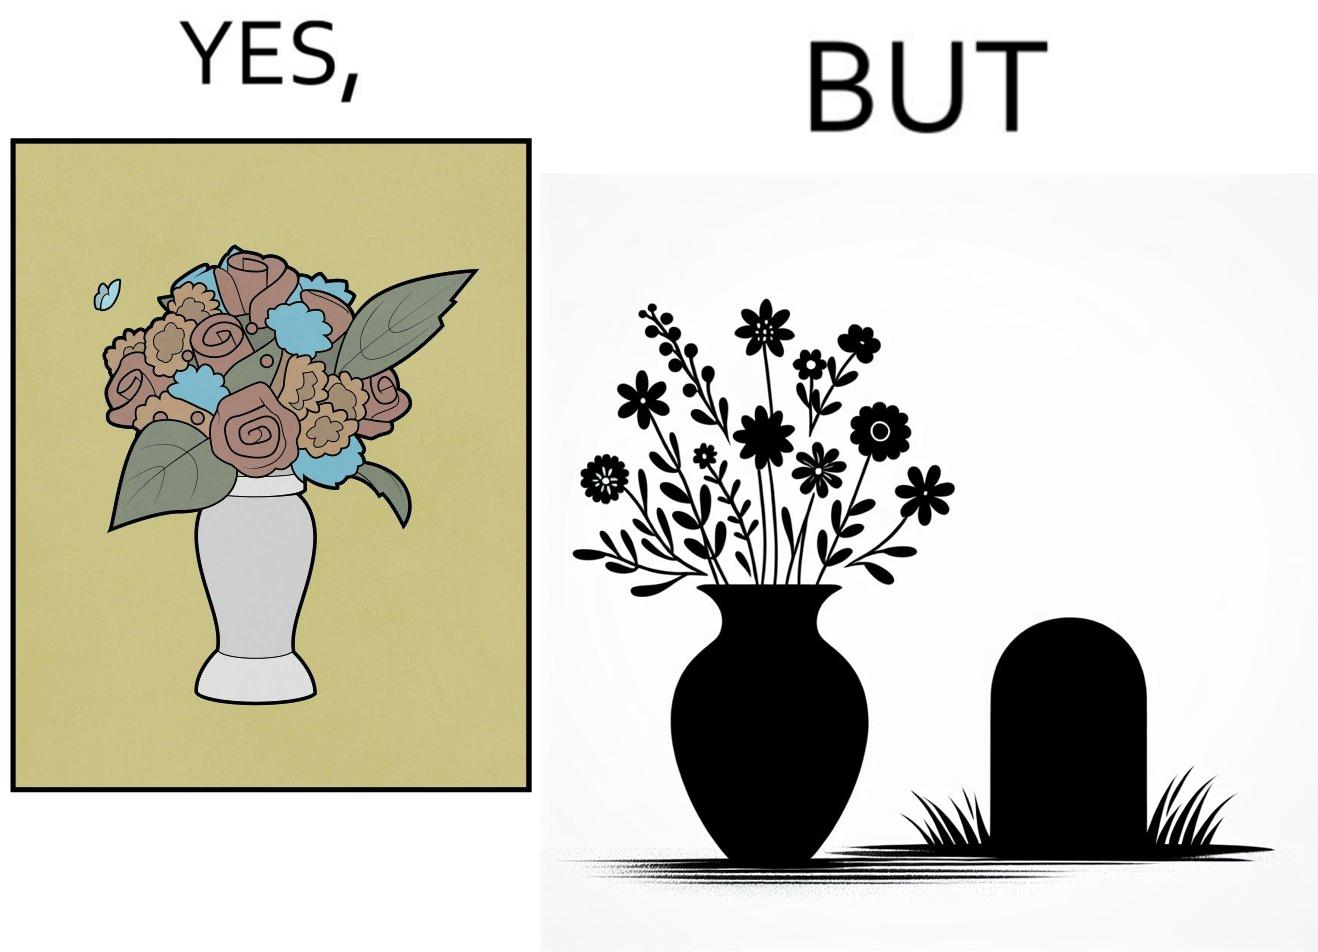What is the satirical meaning behind this image? The image is ironic, because in the first image a vase full of different beautiful flowers is seen which spreads a feeling of positivity, cheerfulness etc., whereas in the second image when the same vase is put in front of a grave stone it produces a feeling of sorrow 